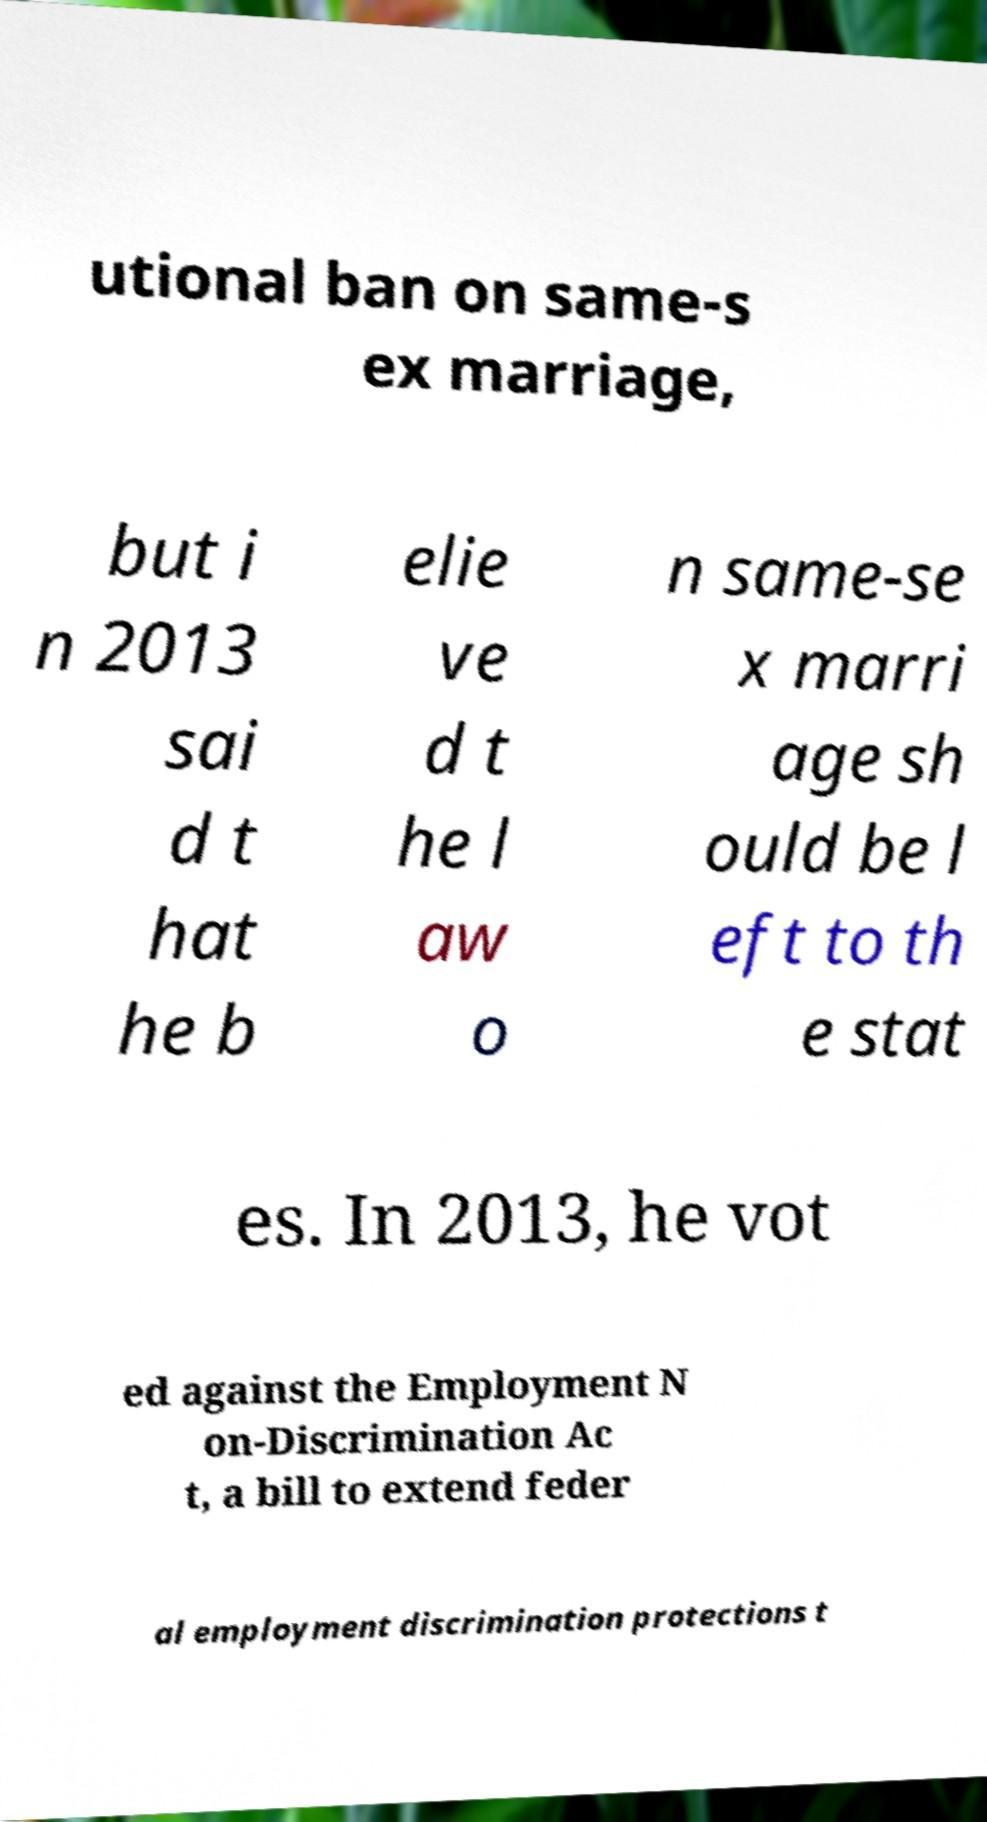Can you accurately transcribe the text from the provided image for me? utional ban on same-s ex marriage, but i n 2013 sai d t hat he b elie ve d t he l aw o n same-se x marri age sh ould be l eft to th e stat es. In 2013, he vot ed against the Employment N on-Discrimination Ac t, a bill to extend feder al employment discrimination protections t 